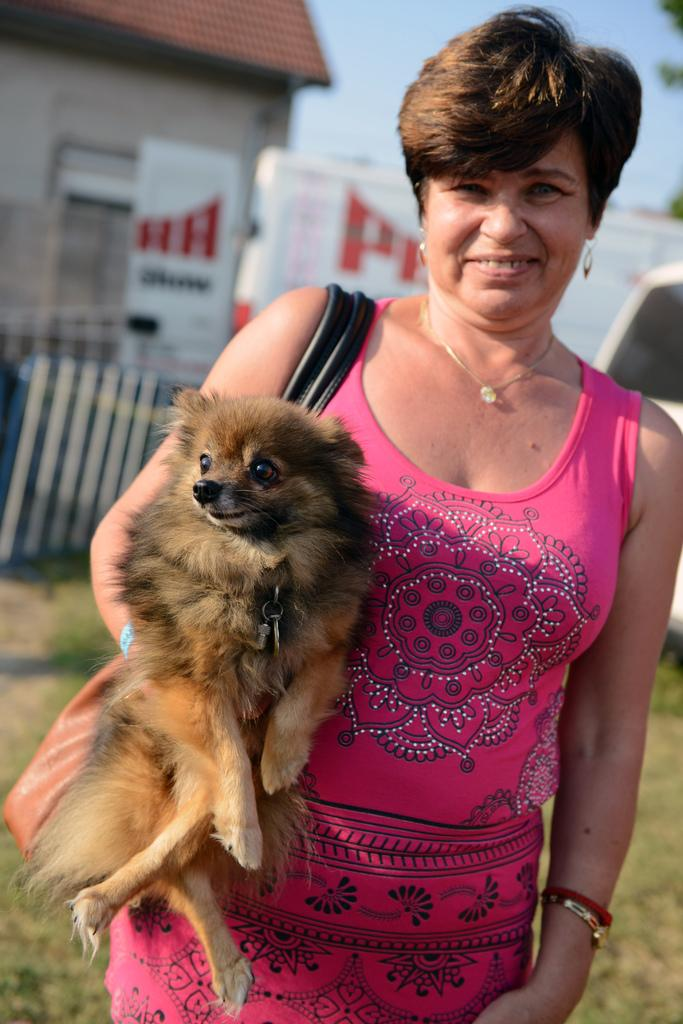Who is the main subject in the image? There is a woman in the image. What is the woman holding in the image? The woman is holding a dog. What can be seen in the background of the image? There is a house visible in the background of the image. What type of apparatus is the woman using to measure the dog's growth in the image? There is no apparatus present in the image, and the woman is not measuring the dog's growth. 